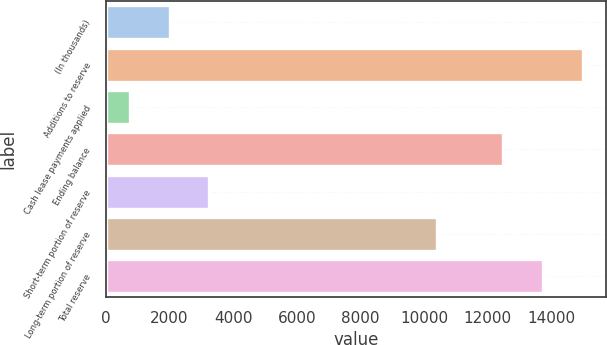<chart> <loc_0><loc_0><loc_500><loc_500><bar_chart><fcel>(In thousands)<fcel>Additions to reserve<fcel>Cash lease payments applied<fcel>Ending balance<fcel>Short-term portion of reserve<fcel>Long-term portion of reserve<fcel>Total reserve<nl><fcel>2006.8<fcel>14973.6<fcel>759<fcel>12478<fcel>3254.6<fcel>10405<fcel>13725.8<nl></chart> 